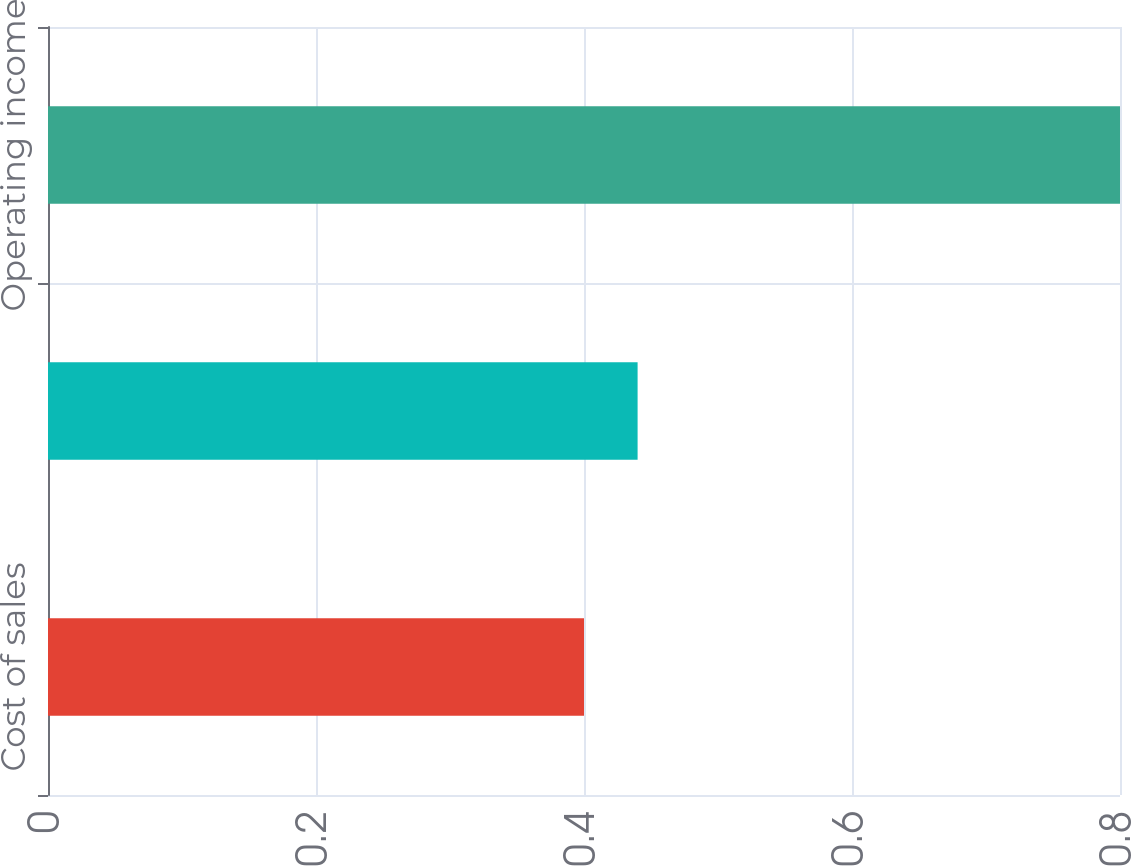Convert chart. <chart><loc_0><loc_0><loc_500><loc_500><bar_chart><fcel>Cost of sales<fcel>Selling general and<fcel>Operating income<nl><fcel>0.4<fcel>0.44<fcel>0.8<nl></chart> 